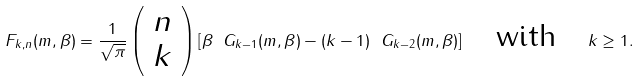<formula> <loc_0><loc_0><loc_500><loc_500>F _ { k , n } ( m , \beta ) = \frac { 1 } { \sqrt { \pi } } \left ( \begin{array} { c } n \\ k \end{array} \right ) \left [ \beta \ G _ { k - 1 } ( m , \beta ) - ( k - 1 ) \ G _ { k - 2 } ( m , \beta ) \right ] \quad \text {with} \quad k \geq 1 .</formula> 